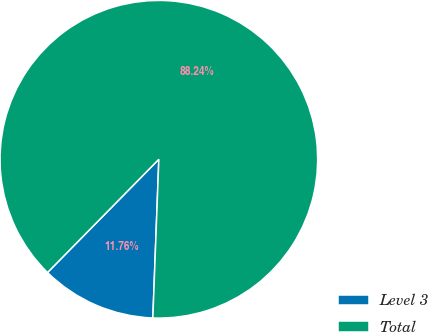<chart> <loc_0><loc_0><loc_500><loc_500><pie_chart><fcel>Level 3<fcel>Total<nl><fcel>11.76%<fcel>88.24%<nl></chart> 